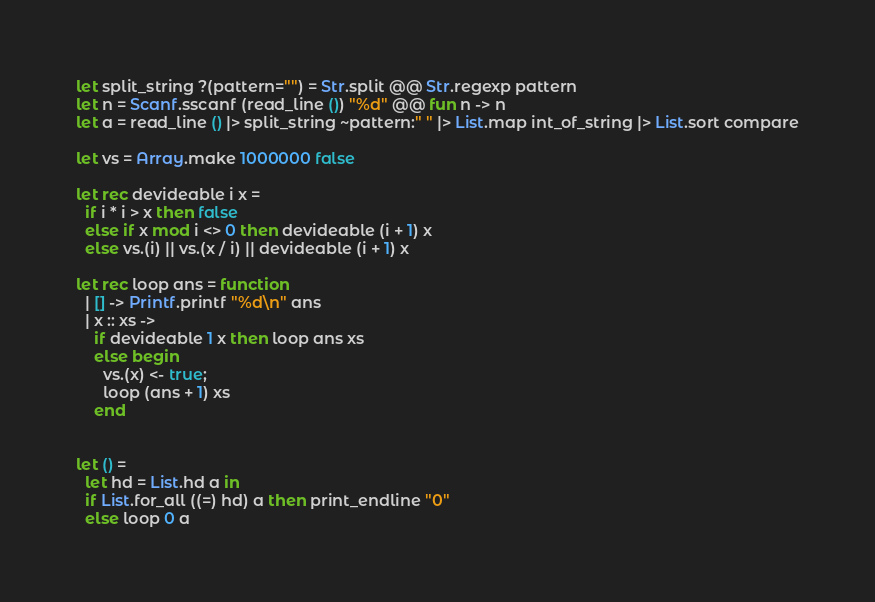Convert code to text. <code><loc_0><loc_0><loc_500><loc_500><_OCaml_>let split_string ?(pattern="") = Str.split @@ Str.regexp pattern
let n = Scanf.sscanf (read_line ()) "%d" @@ fun n -> n
let a = read_line () |> split_string ~pattern:" " |> List.map int_of_string |> List.sort compare

let vs = Array.make 1000000 false

let rec devideable i x =
  if i * i > x then false
  else if x mod i <> 0 then devideable (i + 1) x
  else vs.(i) || vs.(x / i) || devideable (i + 1) x

let rec loop ans = function
  | [] -> Printf.printf "%d\n" ans
  | x :: xs -> 
    if devideable 1 x then loop ans xs
    else begin
      vs.(x) <- true;
      loop (ans + 1) xs
    end


let () = 
  let hd = List.hd a in
  if List.for_all ((=) hd) a then print_endline "0"
  else loop 0 a
</code> 